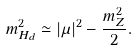<formula> <loc_0><loc_0><loc_500><loc_500>m _ { H _ { d } } ^ { 2 } \simeq | \mu | ^ { 2 } - \frac { m _ { Z } ^ { 2 } } { 2 } .</formula> 